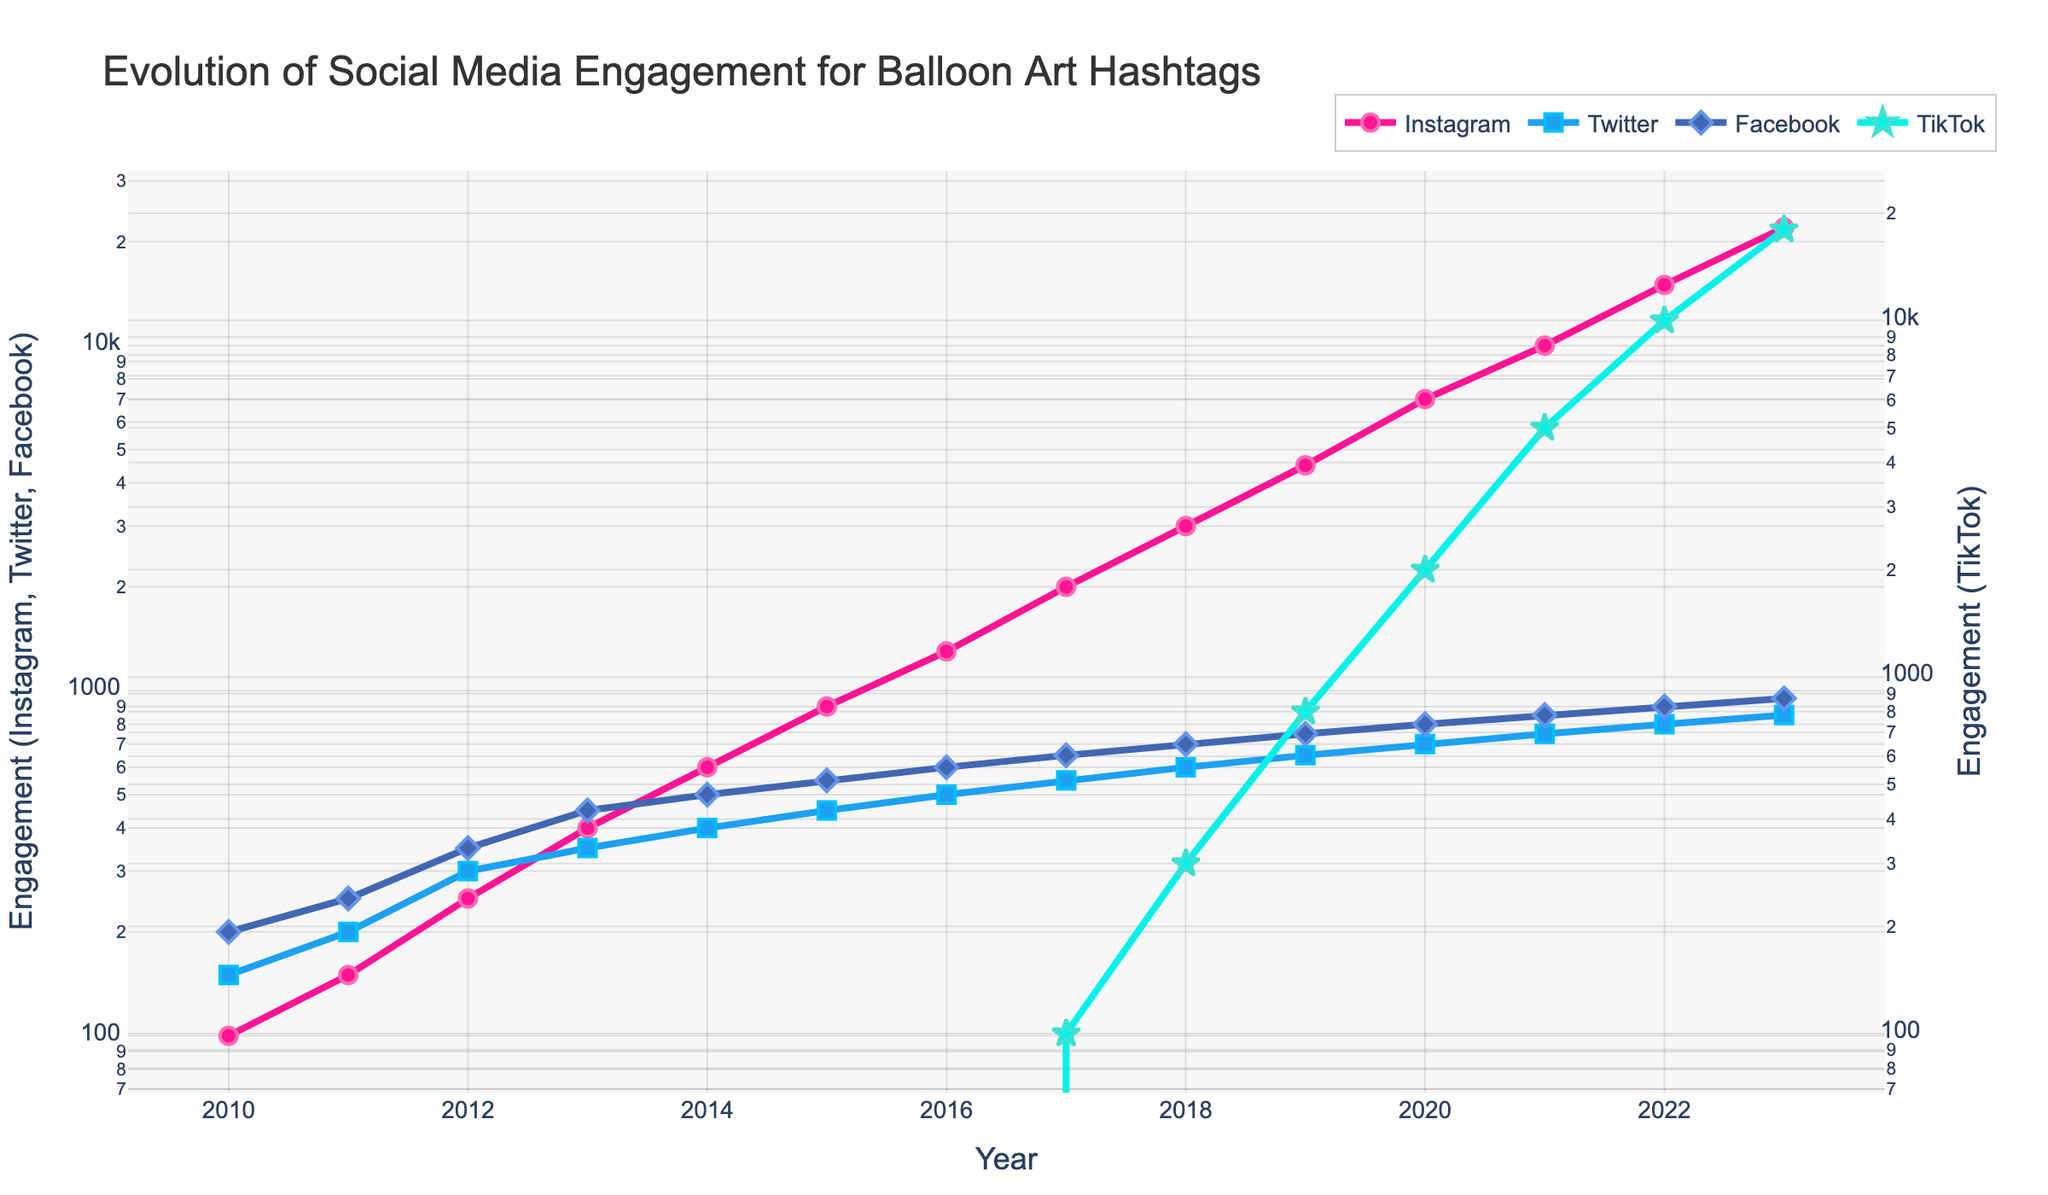Which platform saw the highest engagement in 2023? By looking at the highest point on the graph for each platform in 2023, you can find that Instagram has the highest engagement.
Answer: Instagram Between 2010 and 2015, which platform experienced the most significant overall increase in engagement? By calculating the increase for each platform from 2010 to 2015: 
- Instagram: 900 - 100 = 800
- Twitter: 450 - 150 = 300
- Facebook: 550 - 200 = 350
- TikTok: 0
Instagram has the most significant increase.
Answer: Instagram In which year did TikTok engagement surpass 1,000? By tracing the line for TikTok on the graph, you'll find that TikTok’s engagement surpassed 1,000 in the year 2020.
Answer: 2020 Which year marks the first instance where engagement on Instagram surpassed 2,000? By following the line for Instagram, you can see that in 2017, engagement first surpasses 2,000.
Answer: 2017 Considering all years, which platform has the least variation in engagement? By observing the changes in the y-values for each platform over the years, Twitter shows the smallest variation in engagement.
Answer: Twitter From 2010 to 2023, which year showed the highest increase in total engagement across all platforms combined? To find this, calculate the total engagement for each year and determine the year with the largest increase:
- 2019 to 2020: (7000+700+800+2000) - (4500+650+750+800) = 10500 - 6700 = 3800
This year shows the highest increase.
Answer: 2020 When comparing 2022 and 2023, which platform had the largest proportional increase in engagement? Calculate the proportional increase for each platform: 
- Instagram: (22000 - 15000)/15000 ≈ 0.4667
- Twitter: (850 - 800)/800 = 0.0625
- Facebook: (950 - 900)/900 ≈ 0.0556
- TikTok: (18000 - 10000)/10000 = 0.8
TikTok had the largest proportional increase.
Answer: TikTok How does Facebook engagement in 2016 compare to Twitter engagement in 2023? In 2016, Facebook engagement was 600, and in 2023, Twitter engagement was 850. Since 850 is greater than 600, Facebook engagement in 2016 is less than Twitter engagement in 2023.
Answer: Twitter engagement in 2023 is higher Which year did Twitter's engagement trend start to flatten compared to the continuous growth of Instagram? Observing the trends, around 2013, Twitter’s engagement starts to significantly flatten while Instagram continues on a strong upward trend.
Answer: 2013 What was the average engagement of Facebook between 2010 and 2015? By adding the Facebook engagement values from 2010 to 2015 (200 + 250 + 350 + 450 + 500 + 550) and dividing by 6, we get the average:
(200 + 250 + 350 + 450 + 500 + 550) / 6 = 2250 / 6 = 375
Answer: 375 